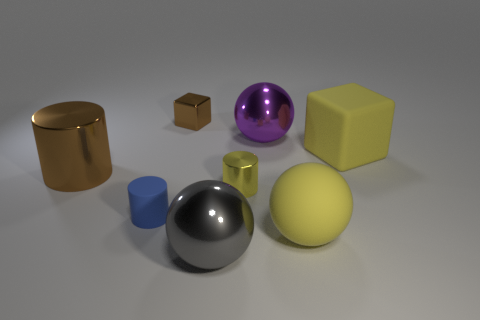Add 1 tiny gray cylinders. How many objects exist? 9 Subtract all blocks. How many objects are left? 6 Subtract all cubes. Subtract all big gray shiny objects. How many objects are left? 5 Add 2 big purple things. How many big purple things are left? 3 Add 2 gray metal spheres. How many gray metal spheres exist? 3 Subtract 0 cyan cubes. How many objects are left? 8 